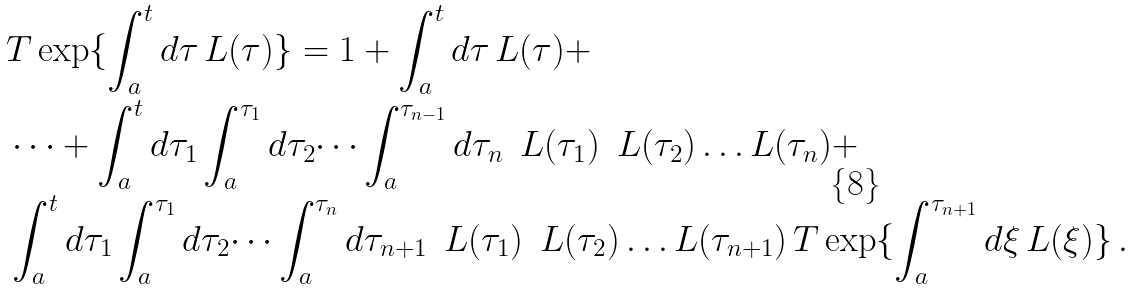<formula> <loc_0><loc_0><loc_500><loc_500>& { T } \exp \{ \int _ { a } ^ { t } d \tau \, { L } ( \tau ) \} = { 1 } + \int _ { a } ^ { t } d \tau \, { L } ( \tau ) + \\ & \dots + \int _ { a } ^ { t } d \tau _ { 1 } \int _ { a } ^ { \tau _ { 1 } } d \tau _ { 2 } \dots \int _ { a } ^ { \tau _ { n - 1 } } d \tau _ { n } \, \ { L } ( \tau _ { 1 } ) \, \ { L } ( \tau _ { 2 } ) \dots { L } ( \tau _ { n } ) + \\ & \int _ { a } ^ { t } d \tau _ { 1 } \int _ { a } ^ { \tau _ { 1 } } d \tau _ { 2 } \dots \int _ { a } ^ { \tau _ { n } } d \tau _ { n + 1 } \, \ { L } ( \tau _ { 1 } ) \, \ { L } ( \tau _ { 2 } ) \dots { L } ( \tau _ { n + 1 } ) \, { T } \exp \{ \int _ { a } ^ { \tau _ { n + 1 } } d \xi \, { L } ( \xi ) \} \, .</formula> 